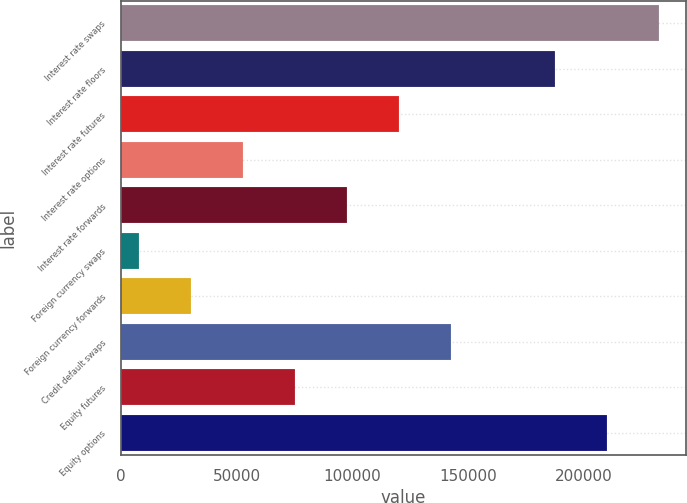Convert chart. <chart><loc_0><loc_0><loc_500><loc_500><bar_chart><fcel>Interest rate swaps<fcel>Interest rate floors<fcel>Interest rate futures<fcel>Interest rate options<fcel>Interest rate forwards<fcel>Foreign currency swaps<fcel>Foreign currency forwards<fcel>Credit default swaps<fcel>Equity futures<fcel>Equity options<nl><fcel>232169<fcel>187244<fcel>119858<fcel>52470.6<fcel>97395.2<fcel>7546<fcel>30008.3<fcel>142320<fcel>74932.9<fcel>209707<nl></chart> 